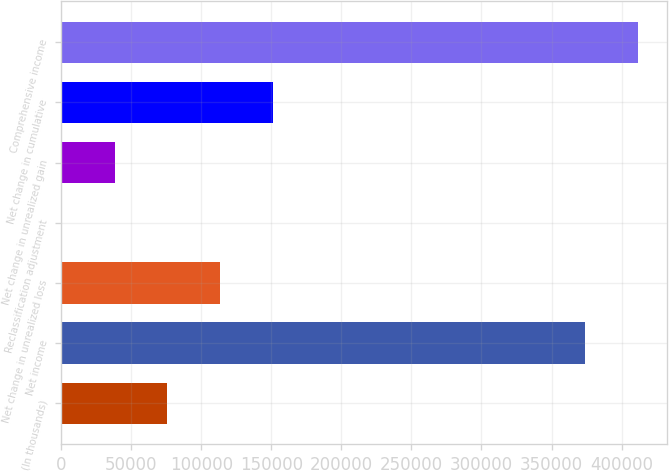Convert chart to OTSL. <chart><loc_0><loc_0><loc_500><loc_500><bar_chart><fcel>(In thousands)<fcel>Net income<fcel>Net change in unrealized loss<fcel>Reclassification adjustment<fcel>Net change in unrealized gain<fcel>Net change in cumulative<fcel>Comprehensive income<nl><fcel>75769.2<fcel>374047<fcel>113329<fcel>649<fcel>38209.1<fcel>150889<fcel>411607<nl></chart> 